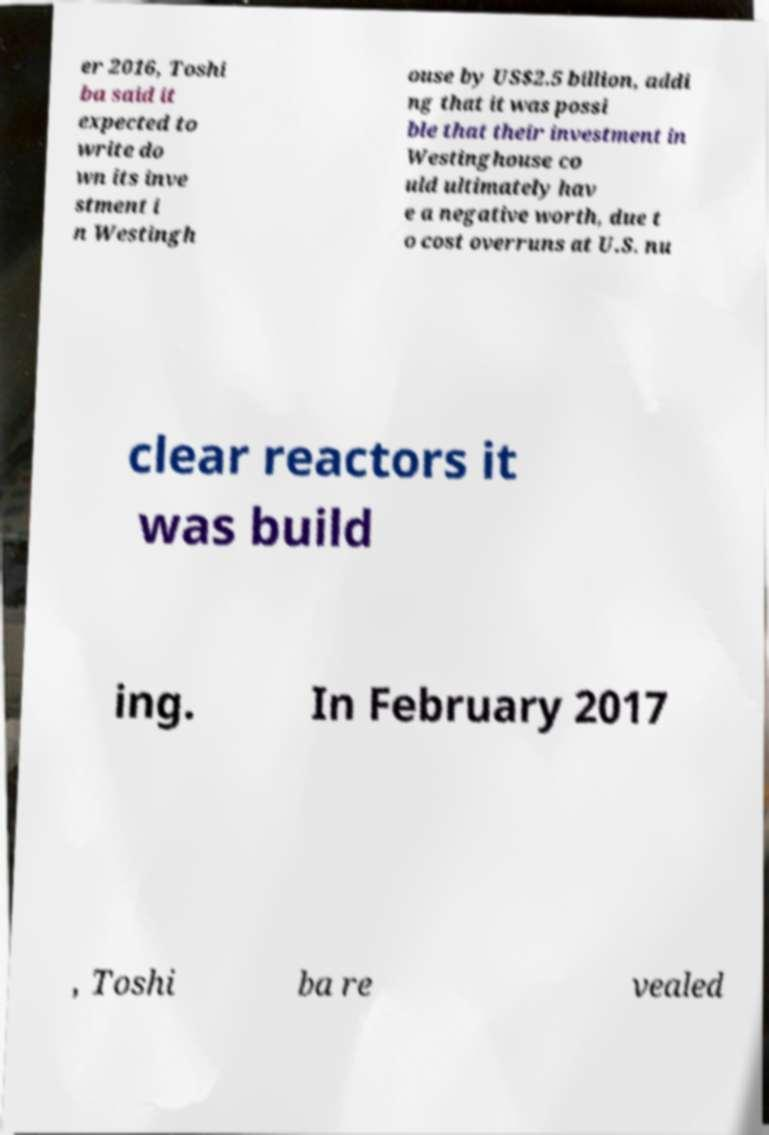There's text embedded in this image that I need extracted. Can you transcribe it verbatim? er 2016, Toshi ba said it expected to write do wn its inve stment i n Westingh ouse by US$2.5 billion, addi ng that it was possi ble that their investment in Westinghouse co uld ultimately hav e a negative worth, due t o cost overruns at U.S. nu clear reactors it was build ing. In February 2017 , Toshi ba re vealed 